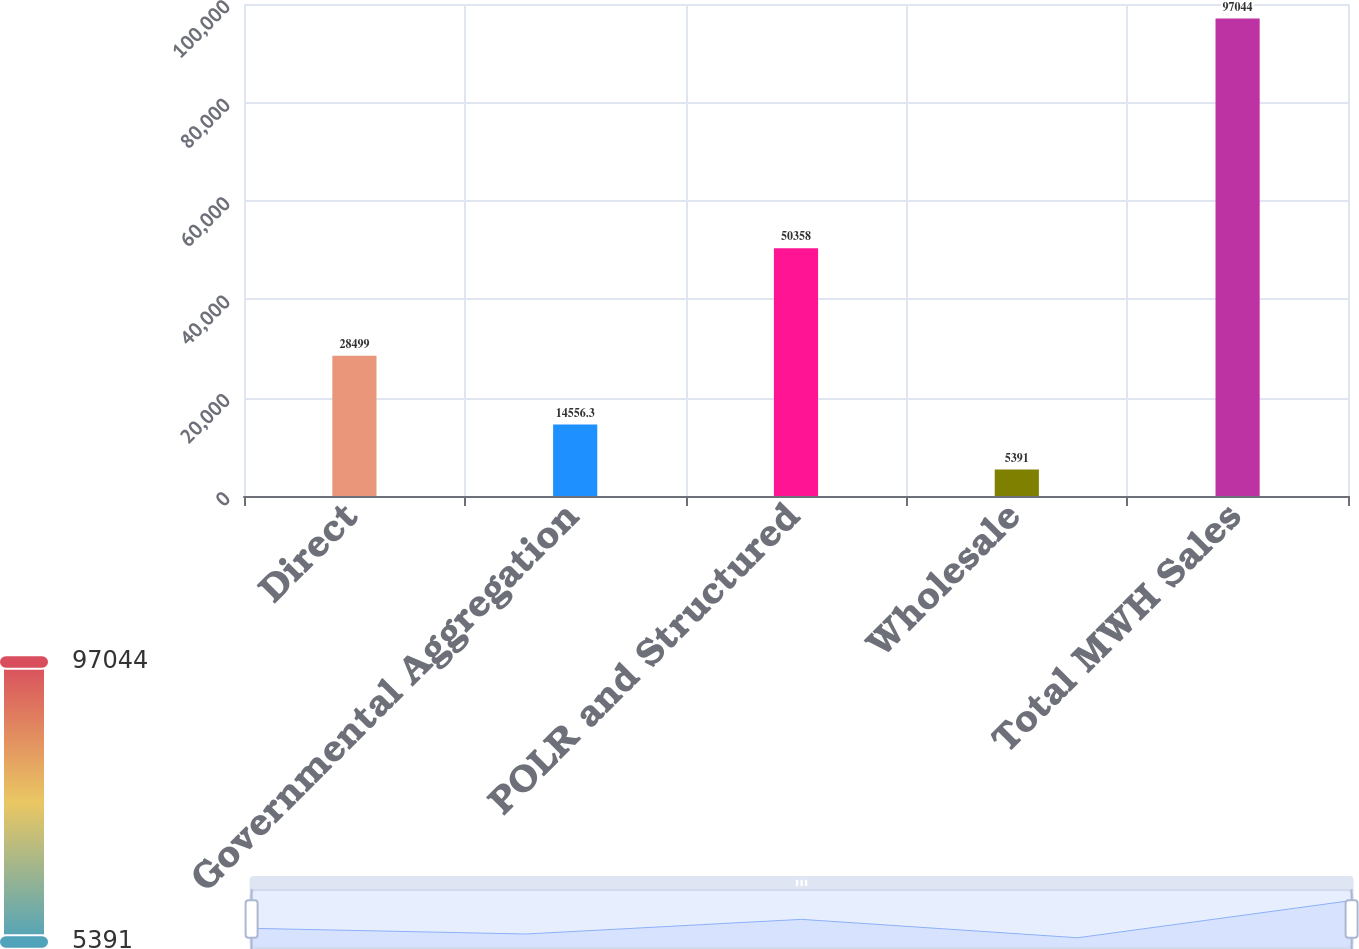Convert chart to OTSL. <chart><loc_0><loc_0><loc_500><loc_500><bar_chart><fcel>Direct<fcel>Governmental Aggregation<fcel>POLR and Structured<fcel>Wholesale<fcel>Total MWH Sales<nl><fcel>28499<fcel>14556.3<fcel>50358<fcel>5391<fcel>97044<nl></chart> 